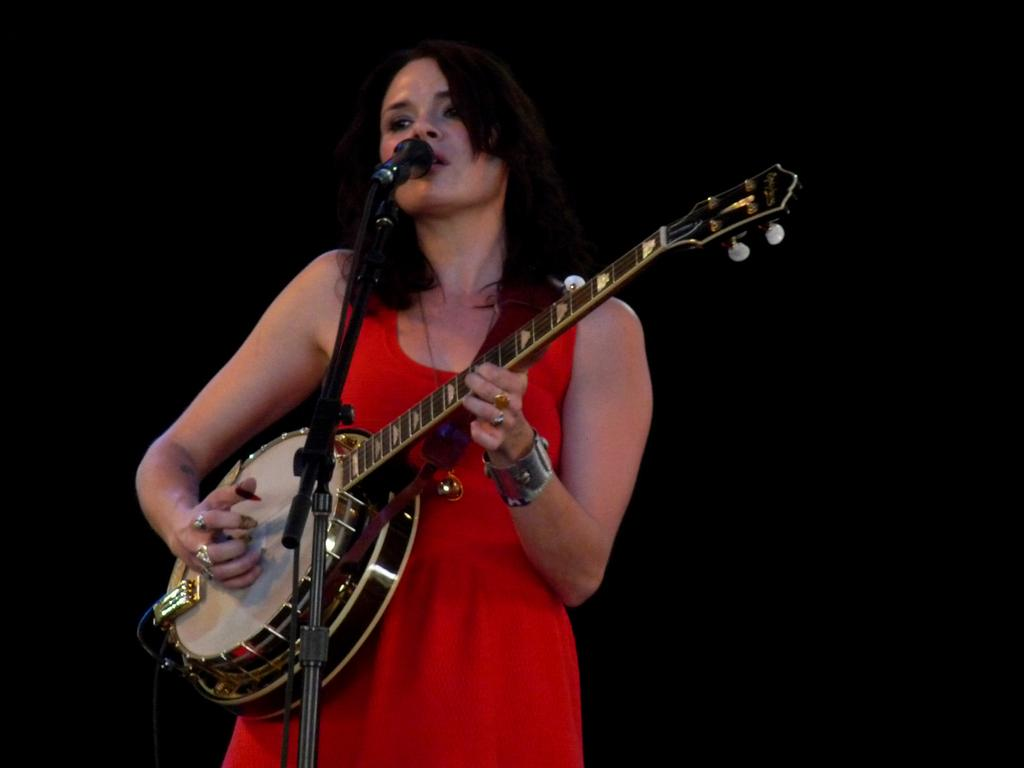Who is the main subject in the image? There is a woman in the image. What is the woman doing in the image? The woman is playing a musical instrument. What can be seen near the woman in the image? There is a mic on a stand in the image. What is the color of the background in the image? The background of the image is dark. What type of impulse can be seen affecting the woman's performance in the image? There is no indication of any impulse affecting the woman's performance in the image. What type of interest does the woman have in the musical instrument she is playing? The image does not provide information about the woman's interest in the musical instrument she is playing. 